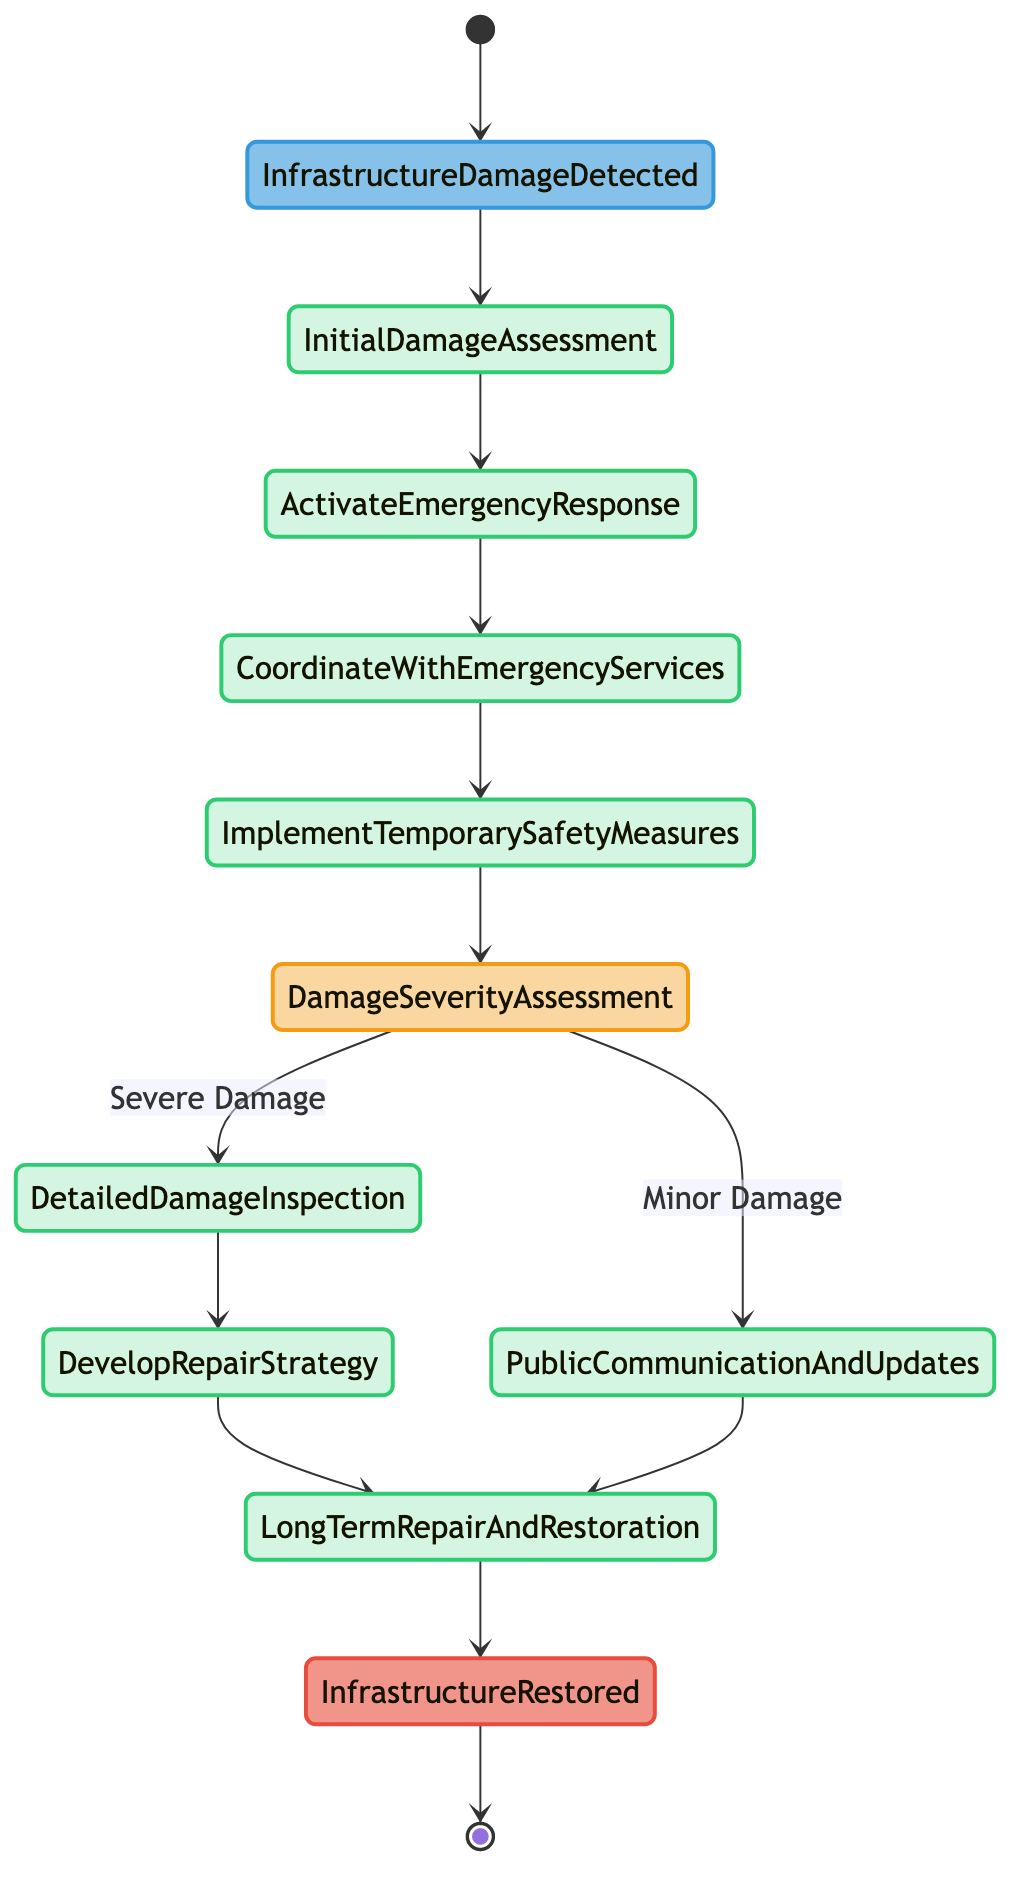What is the first activity after "Infrastructure Damage Detected"? After "Infrastructure Damage Detected," the next activity is "Initial Damage Assessment." This is the immediate step following the detection of infrastructure damage.
Answer: Initial Damage Assessment How many activities are involved in the disaster response process? Counting all activities in the diagram gives us a total of five activities: "Initial Damage Assessment," "Activate Emergency Response," "Coordinate with Emergency Services," "Implement Temporary Safety Measures," and "Long-term Repair and Restoration."
Answer: Five What is the decision point in the diagram? The decision point in the diagram is "Damage Severity Assessment." This is where the flow can split based on whether damage is severe or minor.
Answer: Damage Severity Assessment What happens if the damage is assessed as minor? If the damage is assessed as minor, the process leads directly to "Public Communication and Updates," which indicates a different pathway from that of severe damage.
Answer: Public Communication and Updates What is the last activity before the infrastructure is restored? The last activity before the infrastructure is restored is "Long-term Repair and Restoration." This is the final task that leads to restoring the infrastructure.
Answer: Long-term Repair and Restoration How many nodes are involved in this activity diagram? There are a total of 11 nodes in the diagram, including start events, activities, decisions, and the end event.
Answer: Eleven Which activity follows "Coordinate with Emergency Services"? The activity that follows "Coordinate with Emergency Services" is "Implement Temporary Safety Measures." This is the next step in the response process.
Answer: Implement Temporary Safety Measures What is the outcome of the entire activity diagram? The outcome of the entire activity diagram is "Infrastructure Restored." This indicates that the process concludes with the restoration of the damaged infrastructure.
Answer: Infrastructure Restored 